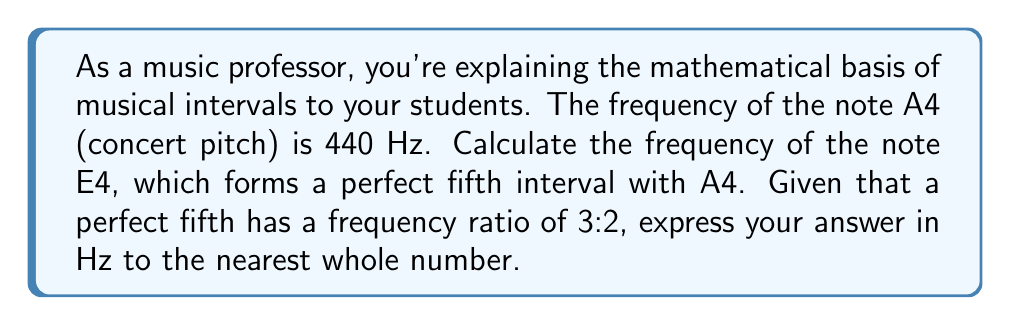What is the answer to this math problem? To solve this problem, we'll follow these steps:

1) First, let's recall the relationship between musical intervals and frequency ratios. A perfect fifth interval has a frequency ratio of 3:2.

2) We're given that A4 has a frequency of 440 Hz, and E4 forms a perfect fifth below A4.

3) To find the frequency of E4, we need to multiply the frequency of A4 by the inverse of the perfect fifth ratio:

   $$f_{E4} = f_{A4} \times \frac{2}{3}$$

4) Let's substitute the known value:

   $$f_{E4} = 440 \text{ Hz} \times \frac{2}{3}$$

5) Now we can calculate:

   $$f_{E4} = \frac{440 \times 2}{3} \text{ Hz} = \frac{880}{3} \text{ Hz} \approx 293.33 \text{ Hz}$$

6) Rounding to the nearest whole number:

   $$f_{E4} \approx 293 \text{ Hz}$$

This mathematical approach demonstrates how the rich tradition of musical notation is deeply rooted in mathematical relationships, specifically frequency ratios.
Answer: 293 Hz 